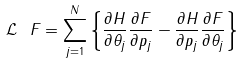<formula> <loc_0><loc_0><loc_500><loc_500>\mathcal { L } \ F = \sum _ { j = 1 } ^ { N } \left \{ \frac { \partial H } { \partial \theta _ { j } } \frac { \partial F } { \partial p _ { j } } - \frac { \partial H } { \partial p _ { j } } \frac { \partial F } { \partial \theta _ { j } } \right \}</formula> 